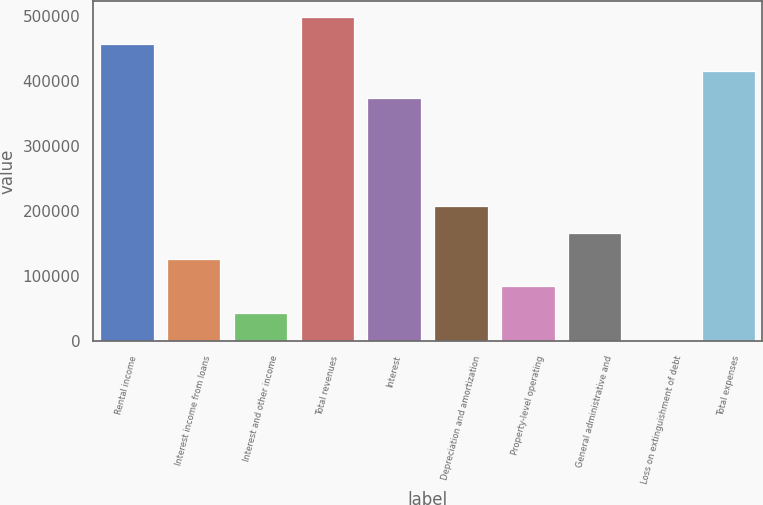Convert chart. <chart><loc_0><loc_0><loc_500><loc_500><bar_chart><fcel>Rental income<fcel>Interest income from loans<fcel>Interest and other income<fcel>Total revenues<fcel>Interest<fcel>Depreciation and amortization<fcel>Property-level operating<fcel>General administrative and<fcel>Loss on extinguishment of debt<fcel>Total expenses<nl><fcel>457310<fcel>125647<fcel>42730.9<fcel>498768<fcel>374394<fcel>208562<fcel>84188.8<fcel>167105<fcel>1273<fcel>415852<nl></chart> 